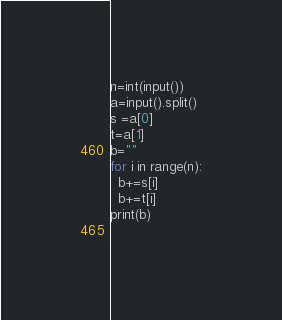<code> <loc_0><loc_0><loc_500><loc_500><_Python_>n=int(input())
a=input().split()
s =a[0]
t=a[1]
b=""
for i in range(n):
  b+=s[i]
  b+=t[i]
print(b)
  </code> 